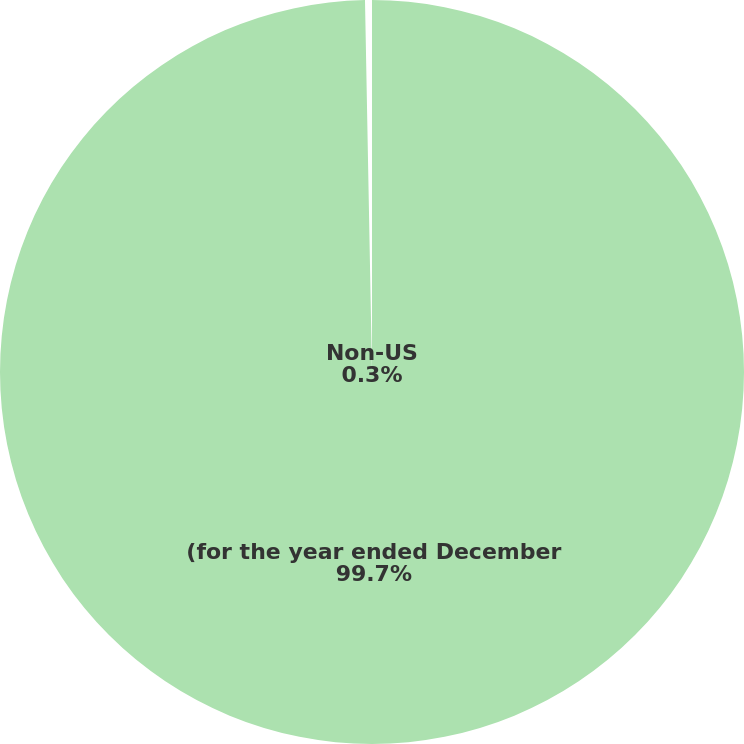Convert chart to OTSL. <chart><loc_0><loc_0><loc_500><loc_500><pie_chart><fcel>(for the year ended December<fcel>Non-US<nl><fcel>99.7%<fcel>0.3%<nl></chart> 